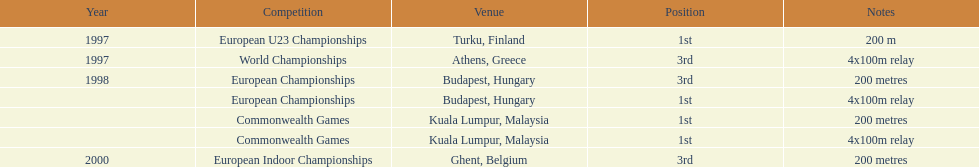During the time period of 1997 to 2000, when did julian golding, a sprinter representing england and the united kingdom, achieve victories in both the 4x100m relay 1998. 